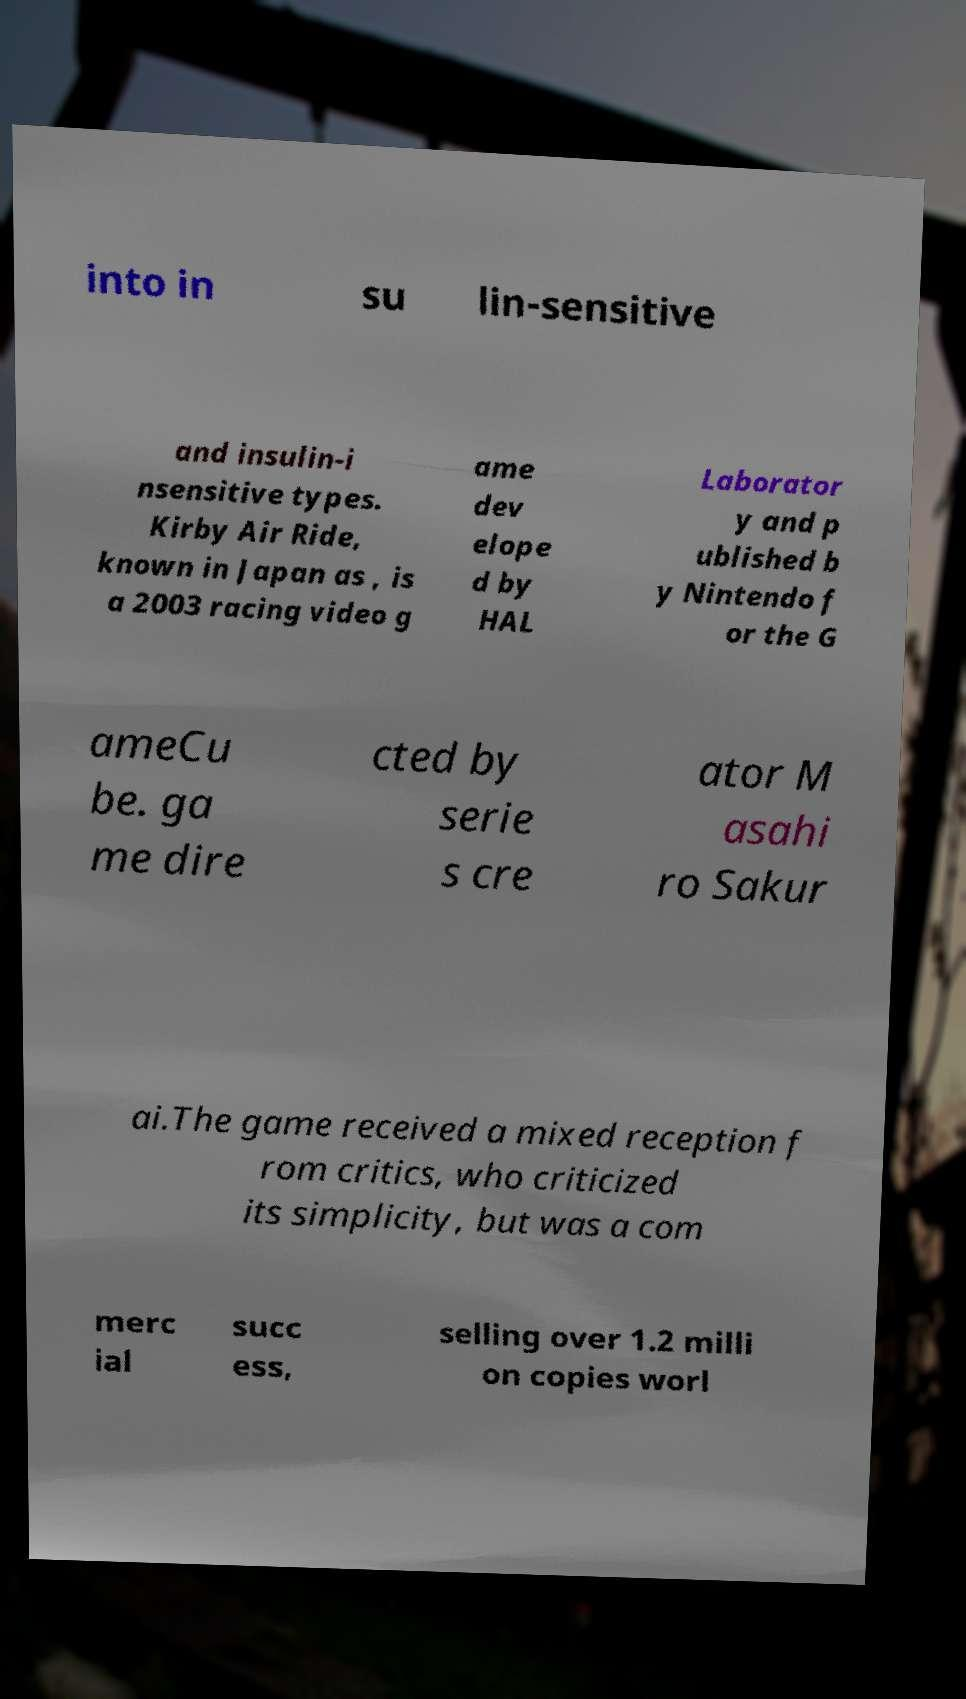Could you assist in decoding the text presented in this image and type it out clearly? into in su lin-sensitive and insulin-i nsensitive types. Kirby Air Ride, known in Japan as , is a 2003 racing video g ame dev elope d by HAL Laborator y and p ublished b y Nintendo f or the G ameCu be. ga me dire cted by serie s cre ator M asahi ro Sakur ai.The game received a mixed reception f rom critics, who criticized its simplicity, but was a com merc ial succ ess, selling over 1.2 milli on copies worl 